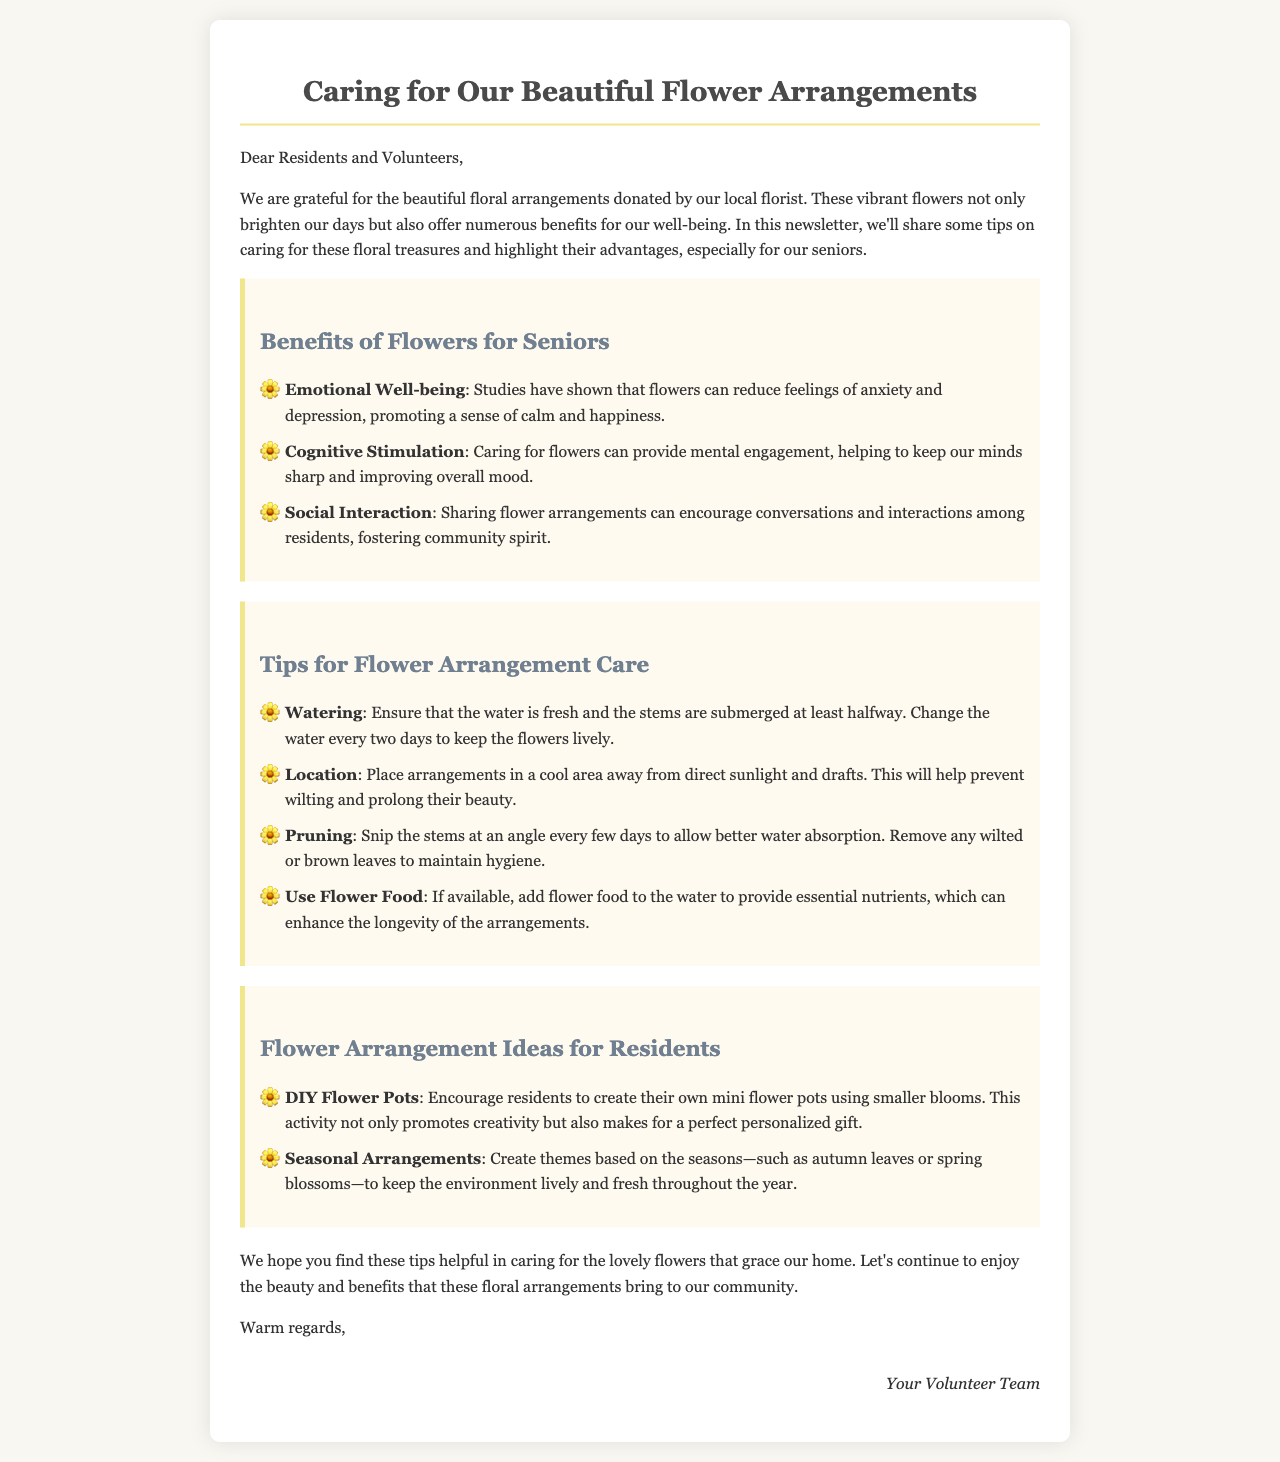What are the emotional benefits of flowers for seniors? The document states that flowers can reduce feelings of anxiety and depression, promoting a sense of calm and happiness.
Answer: Emotional well-being How often should the water be changed for flower arrangements? The document specifies that the water should be changed every two days to keep the flowers lively.
Answer: Every two days What is a suggested activity for residents involving flowers? The document mentions the idea of creating DIY flower pots, which promotes creativity and makes for a personalized gift.
Answer: DIY Flower Pots What should be done to the stems every few days? According to the document, the stems should be snipped at an angle to allow better water absorption.
Answer: Snipped at an angle What is the main purpose of this newsletter? The document indicates that the newsletter aims to share tips on caring for floral arrangements and highlight their benefits for seniors.
Answer: Caring for floral arrangements 